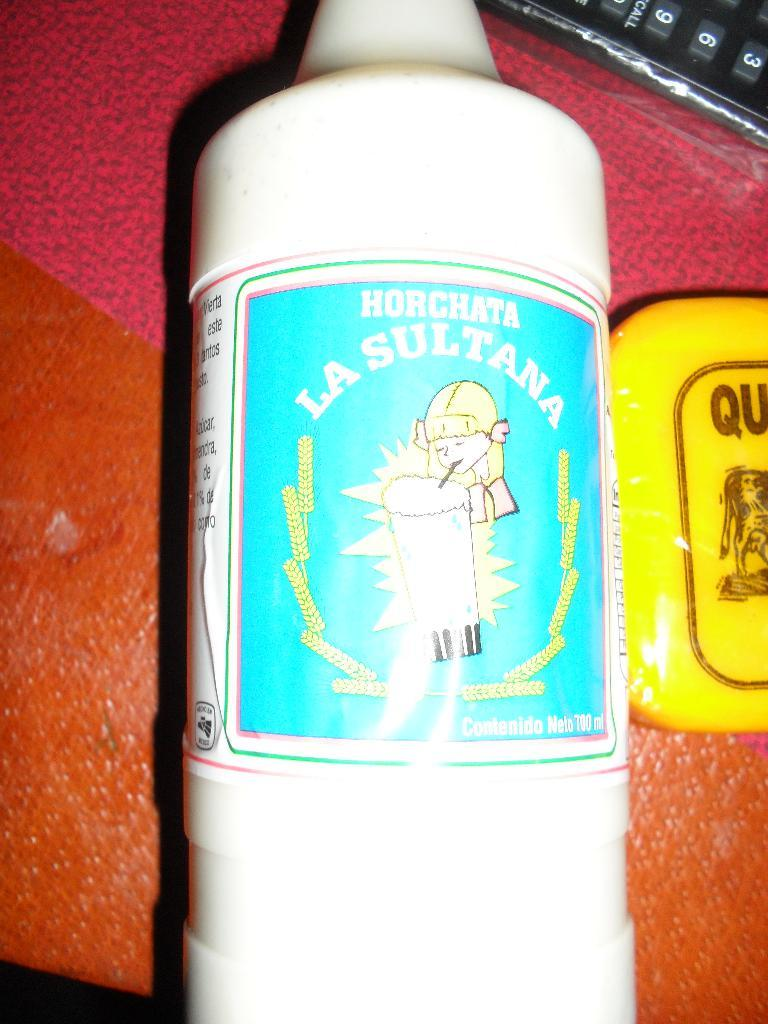<image>
Share a concise interpretation of the image provided. A white bottle of Horchata La Sultana with a blue label. 